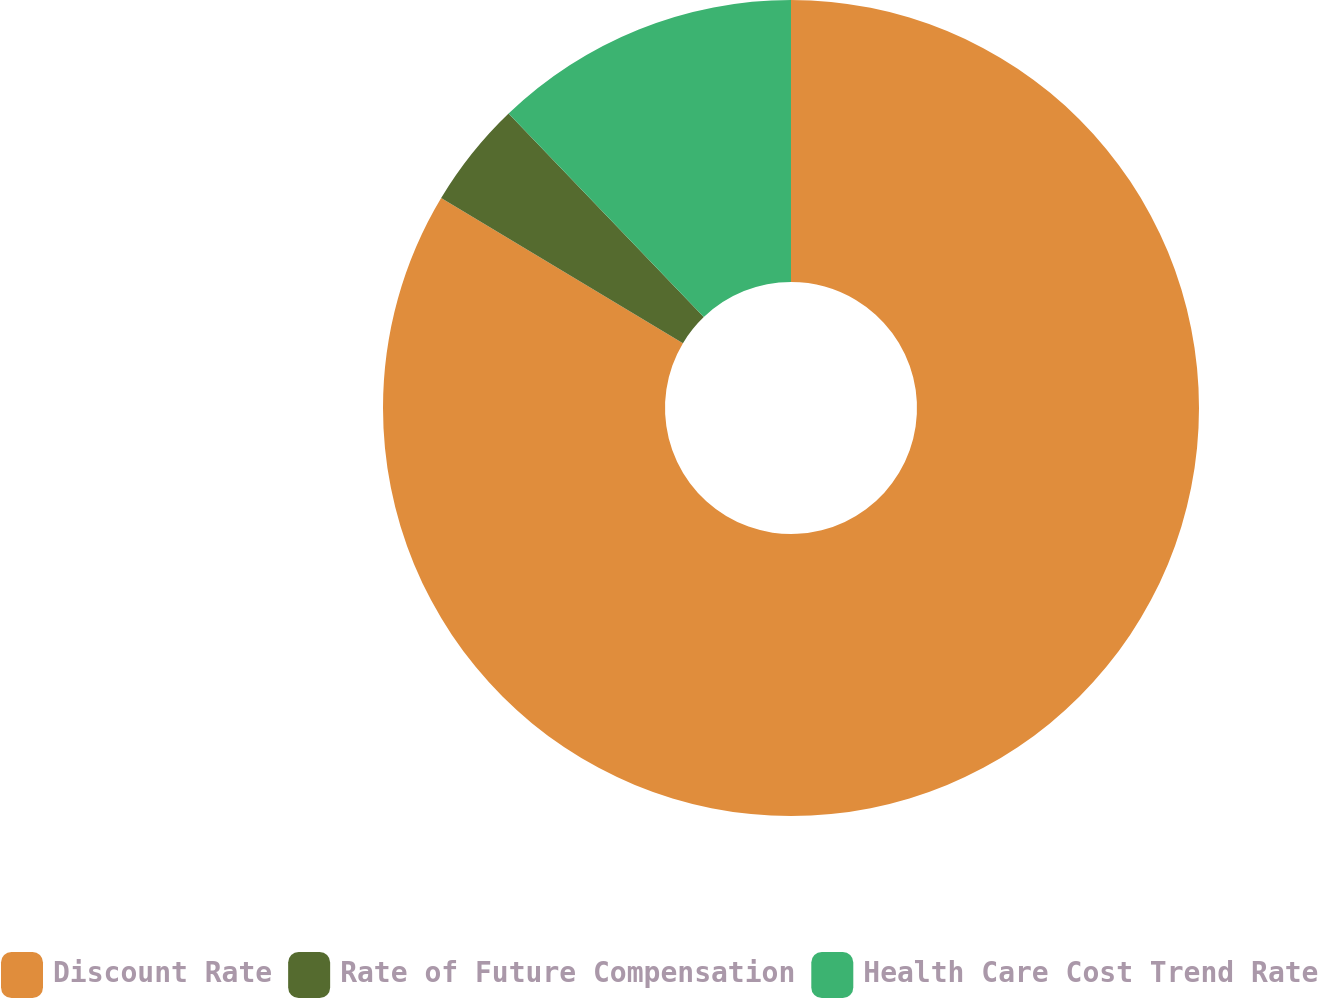Convert chart to OTSL. <chart><loc_0><loc_0><loc_500><loc_500><pie_chart><fcel>Discount Rate<fcel>Rate of Future Compensation<fcel>Health Care Cost Trend Rate<nl><fcel>83.61%<fcel>4.23%<fcel>12.17%<nl></chart> 